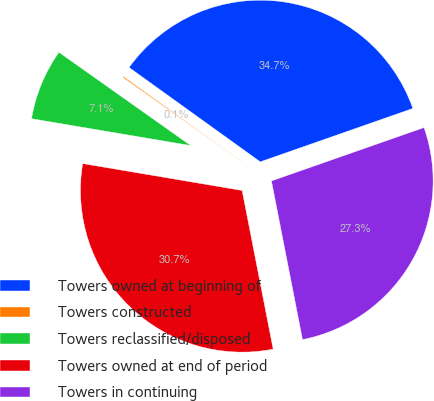Convert chart to OTSL. <chart><loc_0><loc_0><loc_500><loc_500><pie_chart><fcel>Towers owned at beginning of<fcel>Towers constructed<fcel>Towers reclassified/disposed<fcel>Towers owned at end of period<fcel>Towers in continuing<nl><fcel>34.72%<fcel>0.12%<fcel>7.14%<fcel>30.74%<fcel>27.28%<nl></chart> 